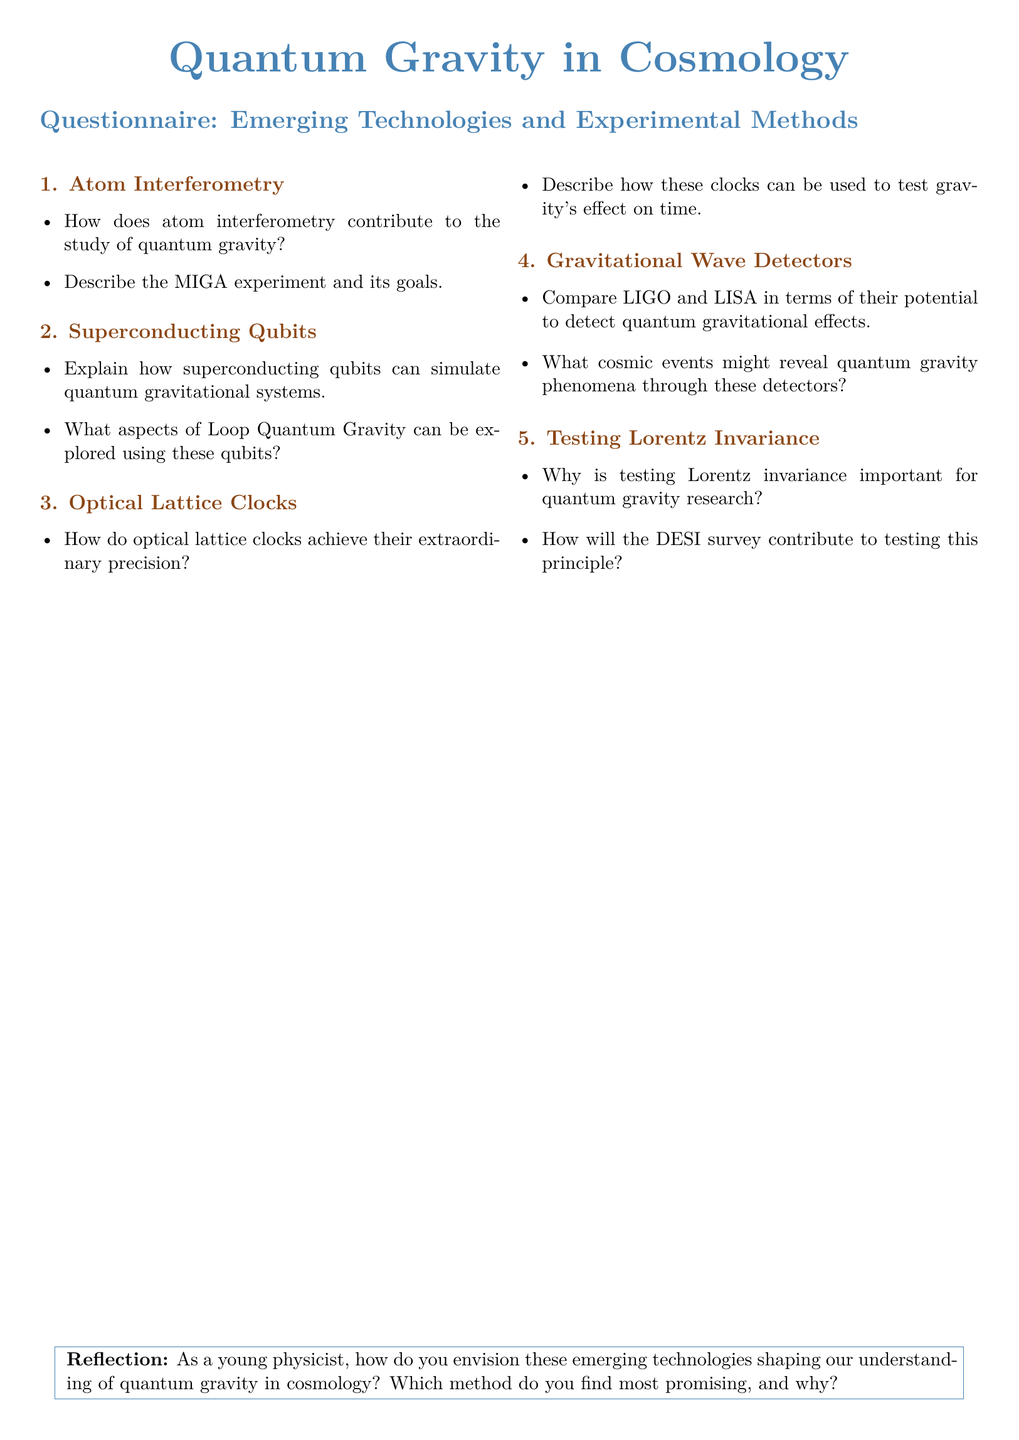What is the title of the document? The title of the document is stated at the top of the rendered document, which is "Quantum Gravity in Cosmology."
Answer: Quantum Gravity in Cosmology How many sections are in the questionnaire? The document contains five distinct subsections under the Questionnaire heading.
Answer: 5 What is the first topic discussed in the questionnaire? The first topic listed in the questionnaire is focused on Atom Interferometry.
Answer: Atom Interferometry Which experiment is mentioned in relation to Atom Interferometry? The MIGA experiment is referenced within the Atom Interferometry section as part of its context.
Answer: MIGA What technology is used to simulate quantum gravitational systems? Superconducting qubits are indicated as the technology capable of simulating quantum gravitational systems.
Answer: Superconducting Qubits What is the purpose of optical lattice clocks in the context of the questionnaire? These clocks are described in the document as tools to test gravity's effect on time.
Answer: Test gravity's effect on time Which two gravitational wave detectors are compared in the document? The document discusses and compares LIGO and LISA in the context of detecting quantum gravitational effects.
Answer: LIGO and LISA What significant principle is emphasized for testing in quantum gravity research? Lorentz invariance is highlighted as an important principle that needs testing in quantum gravity research.
Answer: Lorentz invariance Which survey is mentioned as contributing to testing Lorentz invariance? The document notes that the DESI survey will contribute to testing Lorentz invariance.
Answer: DESI 